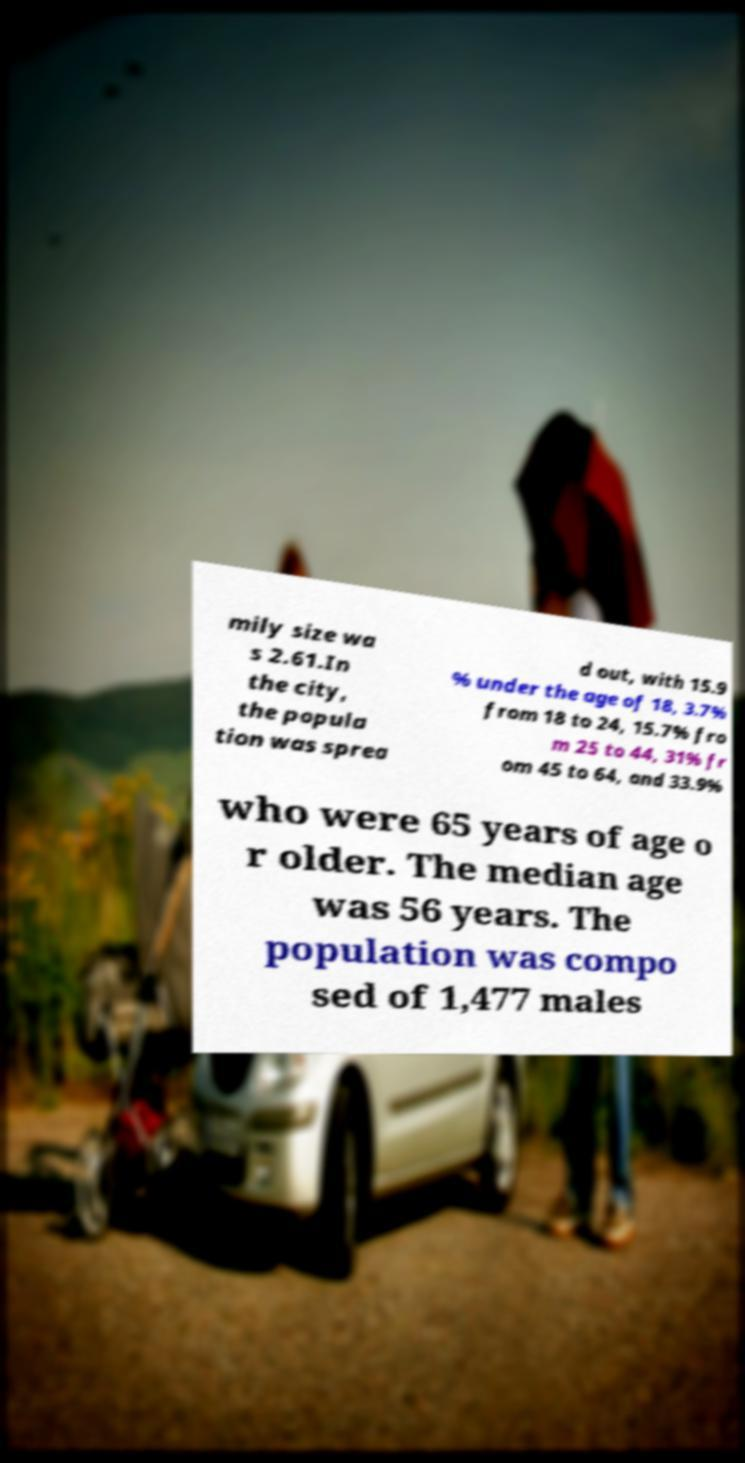Could you assist in decoding the text presented in this image and type it out clearly? mily size wa s 2.61.In the city, the popula tion was sprea d out, with 15.9 % under the age of 18, 3.7% from 18 to 24, 15.7% fro m 25 to 44, 31% fr om 45 to 64, and 33.9% who were 65 years of age o r older. The median age was 56 years. The population was compo sed of 1,477 males 